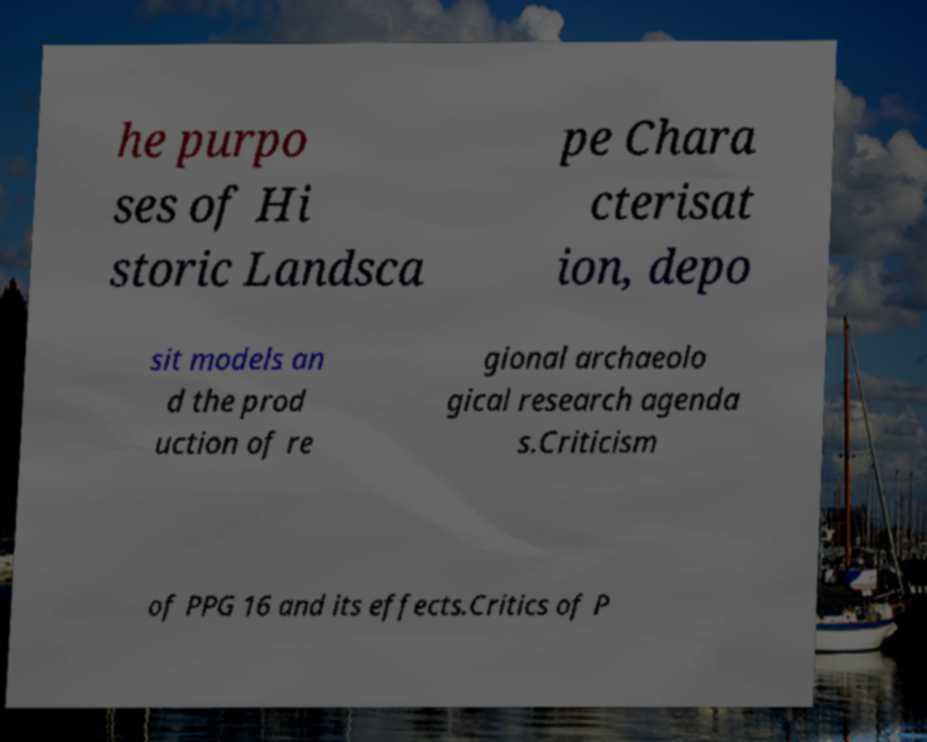Could you extract and type out the text from this image? he purpo ses of Hi storic Landsca pe Chara cterisat ion, depo sit models an d the prod uction of re gional archaeolo gical research agenda s.Criticism of PPG 16 and its effects.Critics of P 